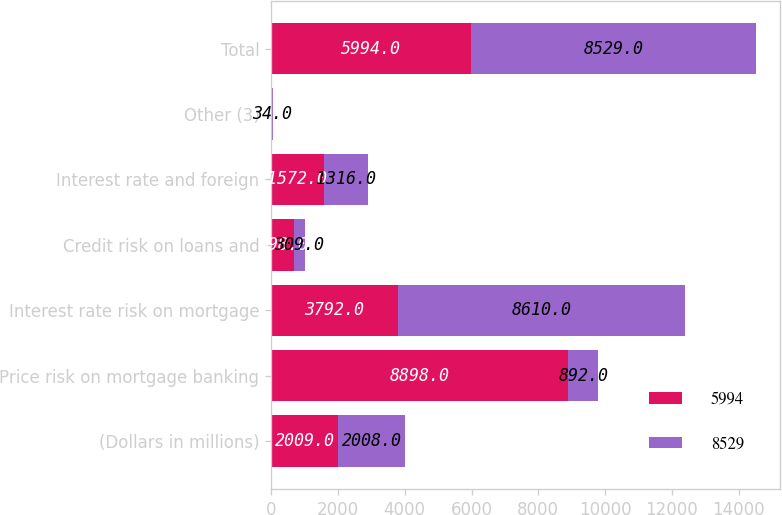<chart> <loc_0><loc_0><loc_500><loc_500><stacked_bar_chart><ecel><fcel>(Dollars in millions)<fcel>Price risk on mortgage banking<fcel>Interest rate risk on mortgage<fcel>Credit risk on loans and<fcel>Interest rate and foreign<fcel>Other (3)<fcel>Total<nl><fcel>5994<fcel>2009<fcel>8898<fcel>3792<fcel>698<fcel>1572<fcel>14<fcel>5994<nl><fcel>8529<fcel>2008<fcel>892<fcel>8610<fcel>309<fcel>1316<fcel>34<fcel>8529<nl></chart> 